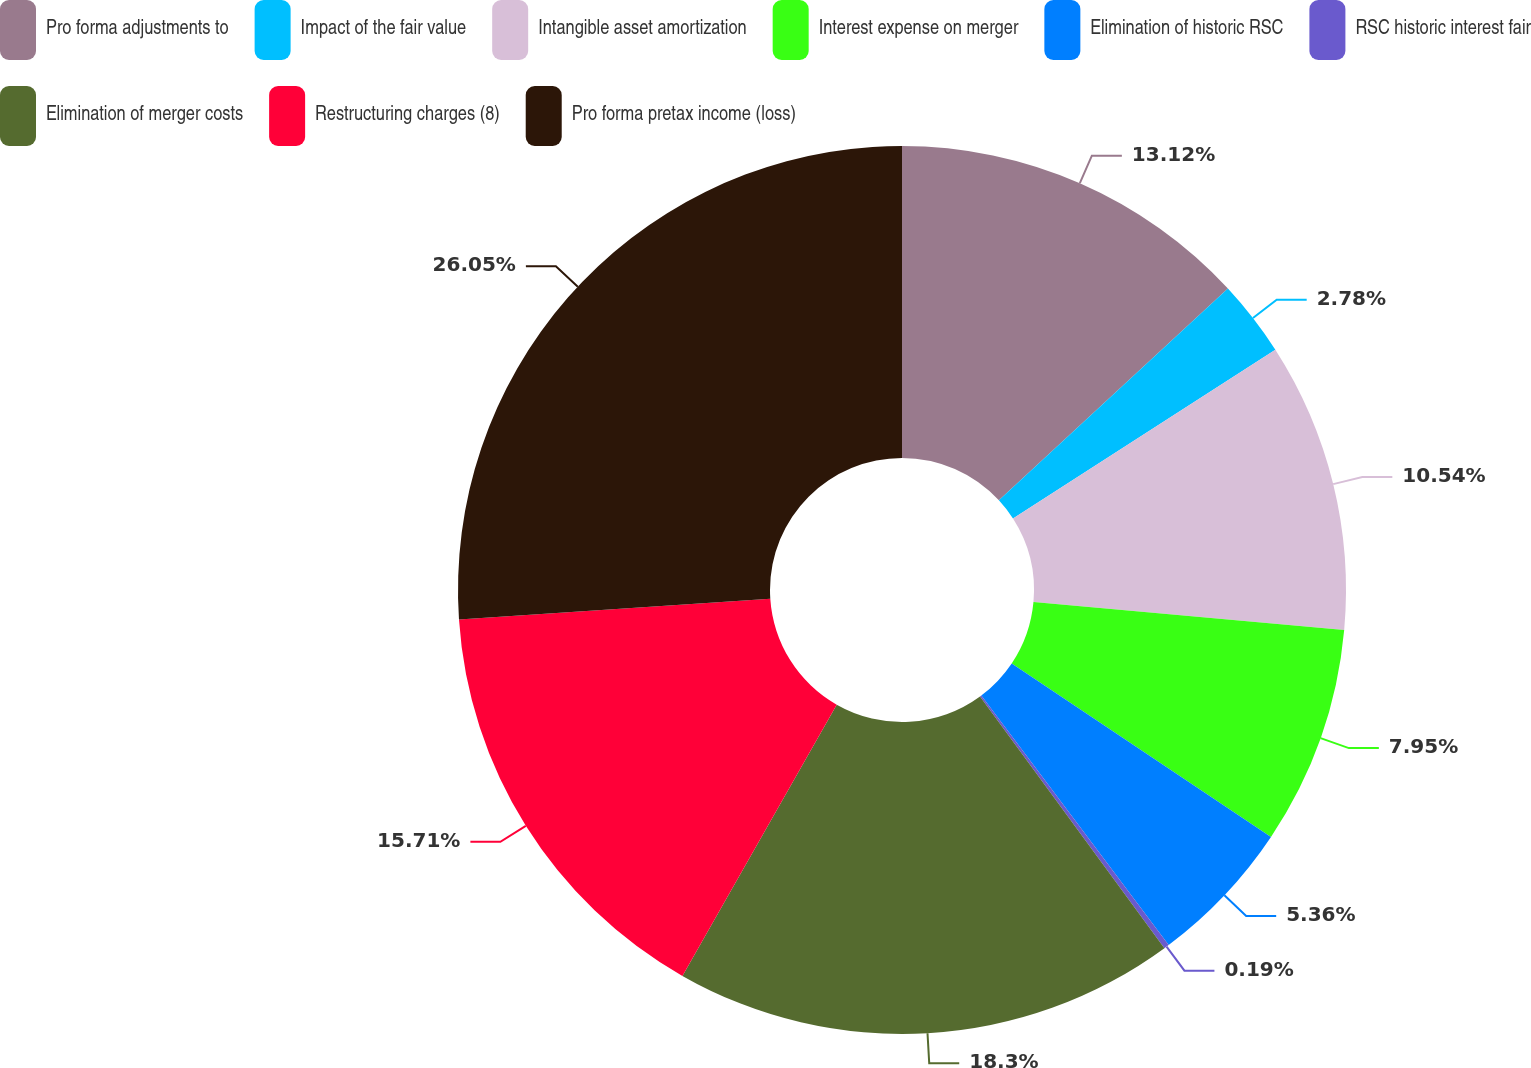Convert chart to OTSL. <chart><loc_0><loc_0><loc_500><loc_500><pie_chart><fcel>Pro forma adjustments to<fcel>Impact of the fair value<fcel>Intangible asset amortization<fcel>Interest expense on merger<fcel>Elimination of historic RSC<fcel>RSC historic interest fair<fcel>Elimination of merger costs<fcel>Restructuring charges (8)<fcel>Pro forma pretax income (loss)<nl><fcel>13.12%<fcel>2.78%<fcel>10.54%<fcel>7.95%<fcel>5.36%<fcel>0.19%<fcel>18.3%<fcel>15.71%<fcel>26.06%<nl></chart> 